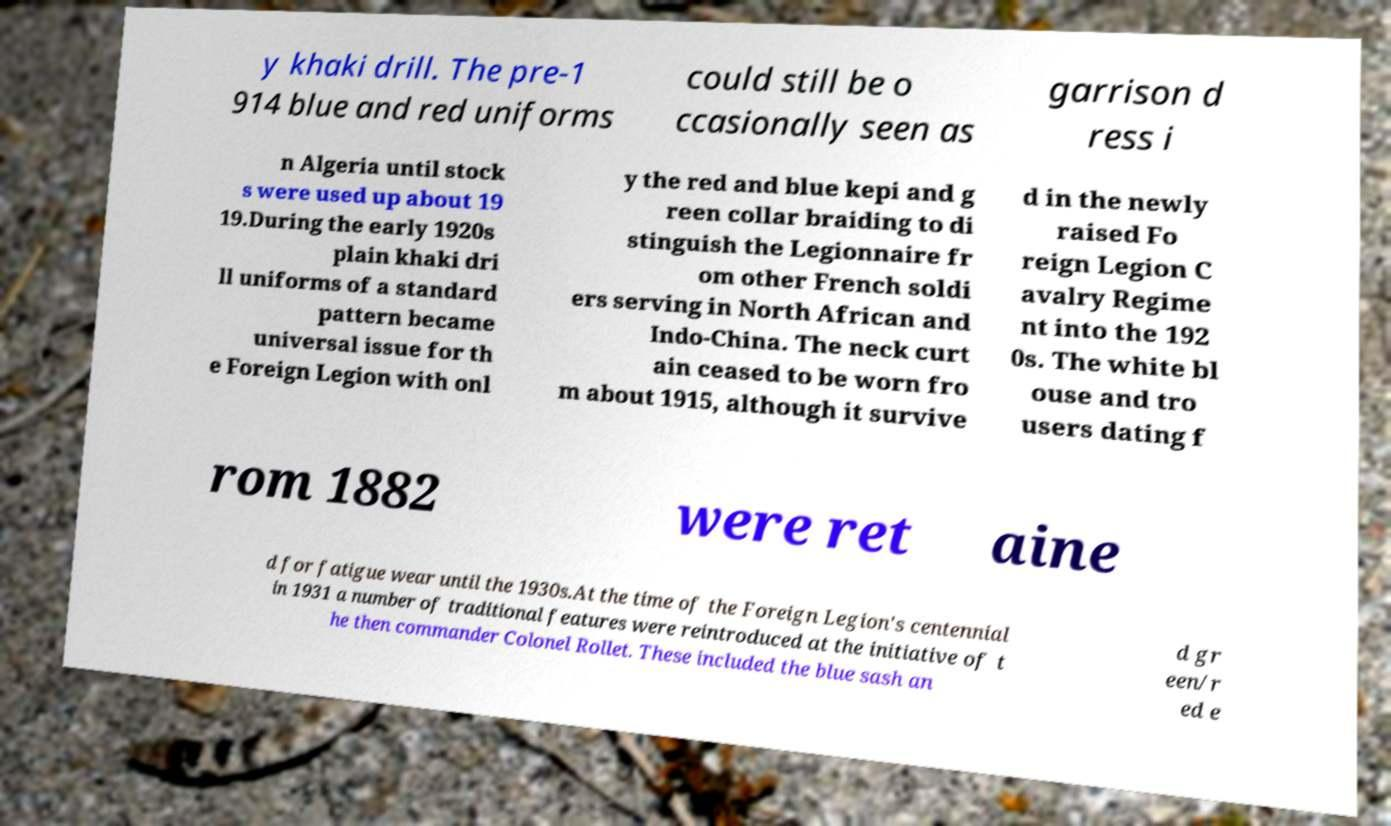Could you assist in decoding the text presented in this image and type it out clearly? y khaki drill. The pre-1 914 blue and red uniforms could still be o ccasionally seen as garrison d ress i n Algeria until stock s were used up about 19 19.During the early 1920s plain khaki dri ll uniforms of a standard pattern became universal issue for th e Foreign Legion with onl y the red and blue kepi and g reen collar braiding to di stinguish the Legionnaire fr om other French soldi ers serving in North African and Indo-China. The neck curt ain ceased to be worn fro m about 1915, although it survive d in the newly raised Fo reign Legion C avalry Regime nt into the 192 0s. The white bl ouse and tro users dating f rom 1882 were ret aine d for fatigue wear until the 1930s.At the time of the Foreign Legion's centennial in 1931 a number of traditional features were reintroduced at the initiative of t he then commander Colonel Rollet. These included the blue sash an d gr een/r ed e 